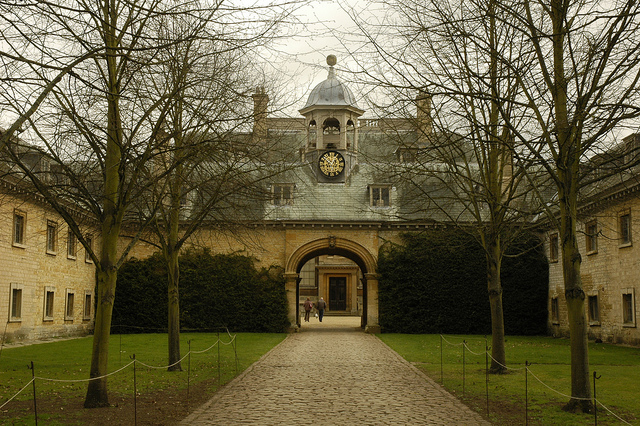<image>What time does the clock say? I am not sure what time the clock says. The time is unclear. What time does the clock say? I don't know what time the clock says. It can be seen '2:45', '2:30', '1:45', '8:50', '6' or '1:00'. 